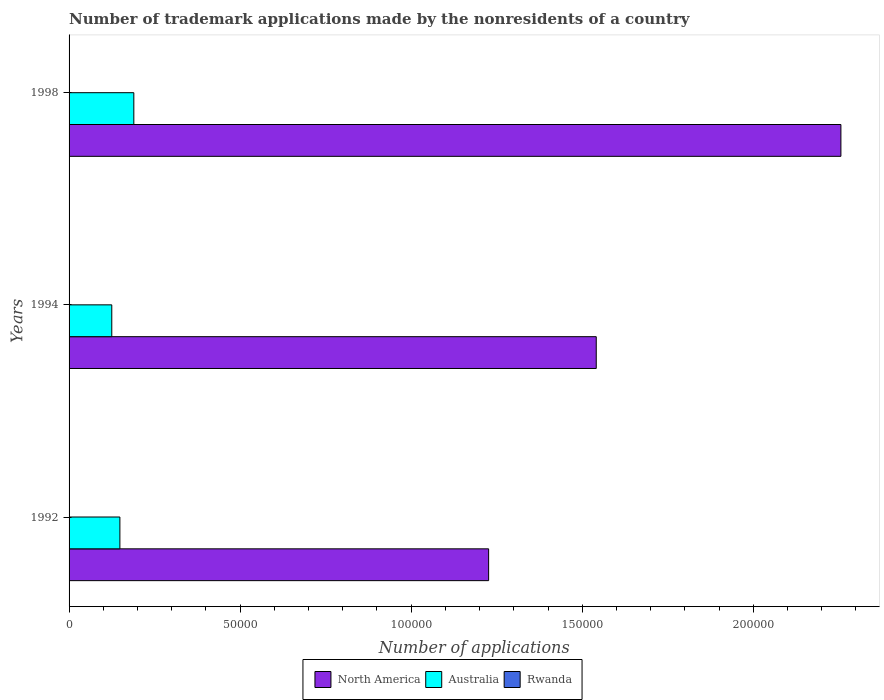Are the number of bars per tick equal to the number of legend labels?
Your response must be concise. Yes. How many bars are there on the 2nd tick from the top?
Offer a terse response. 3. How many bars are there on the 3rd tick from the bottom?
Give a very brief answer. 3. What is the label of the 1st group of bars from the top?
Offer a very short reply. 1998. In how many cases, is the number of bars for a given year not equal to the number of legend labels?
Offer a terse response. 0. What is the number of trademark applications made by the nonresidents in Australia in 1992?
Provide a succinct answer. 1.49e+04. Across all years, what is the maximum number of trademark applications made by the nonresidents in North America?
Your answer should be very brief. 2.26e+05. Across all years, what is the minimum number of trademark applications made by the nonresidents in Australia?
Offer a very short reply. 1.25e+04. In which year was the number of trademark applications made by the nonresidents in Australia maximum?
Your answer should be compact. 1998. What is the total number of trademark applications made by the nonresidents in North America in the graph?
Give a very brief answer. 5.02e+05. What is the difference between the number of trademark applications made by the nonresidents in Rwanda in 1994 and the number of trademark applications made by the nonresidents in North America in 1998?
Offer a very short reply. -2.26e+05. What is the average number of trademark applications made by the nonresidents in Australia per year?
Ensure brevity in your answer.  1.54e+04. In the year 1994, what is the difference between the number of trademark applications made by the nonresidents in Australia and number of trademark applications made by the nonresidents in North America?
Provide a short and direct response. -1.42e+05. Is the number of trademark applications made by the nonresidents in North America in 1994 less than that in 1998?
Offer a very short reply. Yes. Is the difference between the number of trademark applications made by the nonresidents in Australia in 1994 and 1998 greater than the difference between the number of trademark applications made by the nonresidents in North America in 1994 and 1998?
Keep it short and to the point. Yes. What is the difference between the highest and the second highest number of trademark applications made by the nonresidents in Rwanda?
Provide a succinct answer. 1. Is the sum of the number of trademark applications made by the nonresidents in Rwanda in 1994 and 1998 greater than the maximum number of trademark applications made by the nonresidents in Australia across all years?
Make the answer very short. No. What does the 2nd bar from the top in 1998 represents?
Your answer should be compact. Australia. What does the 3rd bar from the bottom in 1998 represents?
Make the answer very short. Rwanda. Are all the bars in the graph horizontal?
Offer a very short reply. Yes. What is the difference between two consecutive major ticks on the X-axis?
Ensure brevity in your answer.  5.00e+04. Are the values on the major ticks of X-axis written in scientific E-notation?
Offer a very short reply. No. Does the graph contain grids?
Keep it short and to the point. No. What is the title of the graph?
Your response must be concise. Number of trademark applications made by the nonresidents of a country. Does "Canada" appear as one of the legend labels in the graph?
Offer a terse response. No. What is the label or title of the X-axis?
Keep it short and to the point. Number of applications. What is the label or title of the Y-axis?
Offer a terse response. Years. What is the Number of applications of North America in 1992?
Ensure brevity in your answer.  1.23e+05. What is the Number of applications in Australia in 1992?
Offer a very short reply. 1.49e+04. What is the Number of applications of Rwanda in 1992?
Ensure brevity in your answer.  3. What is the Number of applications of North America in 1994?
Offer a very short reply. 1.54e+05. What is the Number of applications of Australia in 1994?
Your response must be concise. 1.25e+04. What is the Number of applications of North America in 1998?
Make the answer very short. 2.26e+05. What is the Number of applications of Australia in 1998?
Keep it short and to the point. 1.89e+04. Across all years, what is the maximum Number of applications in North America?
Make the answer very short. 2.26e+05. Across all years, what is the maximum Number of applications of Australia?
Offer a very short reply. 1.89e+04. Across all years, what is the maximum Number of applications in Rwanda?
Your answer should be compact. 4. Across all years, what is the minimum Number of applications of North America?
Offer a very short reply. 1.23e+05. Across all years, what is the minimum Number of applications of Australia?
Your response must be concise. 1.25e+04. Across all years, what is the minimum Number of applications of Rwanda?
Keep it short and to the point. 1. What is the total Number of applications of North America in the graph?
Provide a succinct answer. 5.02e+05. What is the total Number of applications of Australia in the graph?
Keep it short and to the point. 4.63e+04. What is the total Number of applications in Rwanda in the graph?
Offer a very short reply. 8. What is the difference between the Number of applications of North America in 1992 and that in 1994?
Offer a terse response. -3.15e+04. What is the difference between the Number of applications in Australia in 1992 and that in 1994?
Ensure brevity in your answer.  2372. What is the difference between the Number of applications in North America in 1992 and that in 1998?
Offer a terse response. -1.03e+05. What is the difference between the Number of applications in Australia in 1992 and that in 1998?
Your answer should be very brief. -4072. What is the difference between the Number of applications of Rwanda in 1992 and that in 1998?
Your response must be concise. -1. What is the difference between the Number of applications of North America in 1994 and that in 1998?
Provide a succinct answer. -7.15e+04. What is the difference between the Number of applications of Australia in 1994 and that in 1998?
Keep it short and to the point. -6444. What is the difference between the Number of applications in North America in 1992 and the Number of applications in Australia in 1994?
Give a very brief answer. 1.10e+05. What is the difference between the Number of applications in North America in 1992 and the Number of applications in Rwanda in 1994?
Make the answer very short. 1.23e+05. What is the difference between the Number of applications in Australia in 1992 and the Number of applications in Rwanda in 1994?
Your answer should be very brief. 1.49e+04. What is the difference between the Number of applications in North America in 1992 and the Number of applications in Australia in 1998?
Provide a succinct answer. 1.04e+05. What is the difference between the Number of applications in North America in 1992 and the Number of applications in Rwanda in 1998?
Provide a short and direct response. 1.23e+05. What is the difference between the Number of applications in Australia in 1992 and the Number of applications in Rwanda in 1998?
Your response must be concise. 1.49e+04. What is the difference between the Number of applications in North America in 1994 and the Number of applications in Australia in 1998?
Provide a succinct answer. 1.35e+05. What is the difference between the Number of applications of North America in 1994 and the Number of applications of Rwanda in 1998?
Give a very brief answer. 1.54e+05. What is the difference between the Number of applications in Australia in 1994 and the Number of applications in Rwanda in 1998?
Give a very brief answer. 1.25e+04. What is the average Number of applications in North America per year?
Ensure brevity in your answer.  1.67e+05. What is the average Number of applications of Australia per year?
Provide a short and direct response. 1.54e+04. What is the average Number of applications of Rwanda per year?
Give a very brief answer. 2.67. In the year 1992, what is the difference between the Number of applications of North America and Number of applications of Australia?
Your answer should be compact. 1.08e+05. In the year 1992, what is the difference between the Number of applications in North America and Number of applications in Rwanda?
Offer a terse response. 1.23e+05. In the year 1992, what is the difference between the Number of applications of Australia and Number of applications of Rwanda?
Ensure brevity in your answer.  1.49e+04. In the year 1994, what is the difference between the Number of applications of North America and Number of applications of Australia?
Keep it short and to the point. 1.42e+05. In the year 1994, what is the difference between the Number of applications in North America and Number of applications in Rwanda?
Offer a terse response. 1.54e+05. In the year 1994, what is the difference between the Number of applications in Australia and Number of applications in Rwanda?
Your answer should be compact. 1.25e+04. In the year 1998, what is the difference between the Number of applications of North America and Number of applications of Australia?
Offer a very short reply. 2.07e+05. In the year 1998, what is the difference between the Number of applications in North America and Number of applications in Rwanda?
Provide a succinct answer. 2.26e+05. In the year 1998, what is the difference between the Number of applications of Australia and Number of applications of Rwanda?
Provide a short and direct response. 1.89e+04. What is the ratio of the Number of applications of North America in 1992 to that in 1994?
Ensure brevity in your answer.  0.8. What is the ratio of the Number of applications of Australia in 1992 to that in 1994?
Ensure brevity in your answer.  1.19. What is the ratio of the Number of applications of North America in 1992 to that in 1998?
Your answer should be very brief. 0.54. What is the ratio of the Number of applications of Australia in 1992 to that in 1998?
Your response must be concise. 0.78. What is the ratio of the Number of applications of North America in 1994 to that in 1998?
Provide a succinct answer. 0.68. What is the ratio of the Number of applications in Australia in 1994 to that in 1998?
Ensure brevity in your answer.  0.66. What is the ratio of the Number of applications in Rwanda in 1994 to that in 1998?
Provide a short and direct response. 0.25. What is the difference between the highest and the second highest Number of applications in North America?
Make the answer very short. 7.15e+04. What is the difference between the highest and the second highest Number of applications in Australia?
Ensure brevity in your answer.  4072. What is the difference between the highest and the second highest Number of applications of Rwanda?
Give a very brief answer. 1. What is the difference between the highest and the lowest Number of applications of North America?
Your response must be concise. 1.03e+05. What is the difference between the highest and the lowest Number of applications of Australia?
Your answer should be very brief. 6444. 